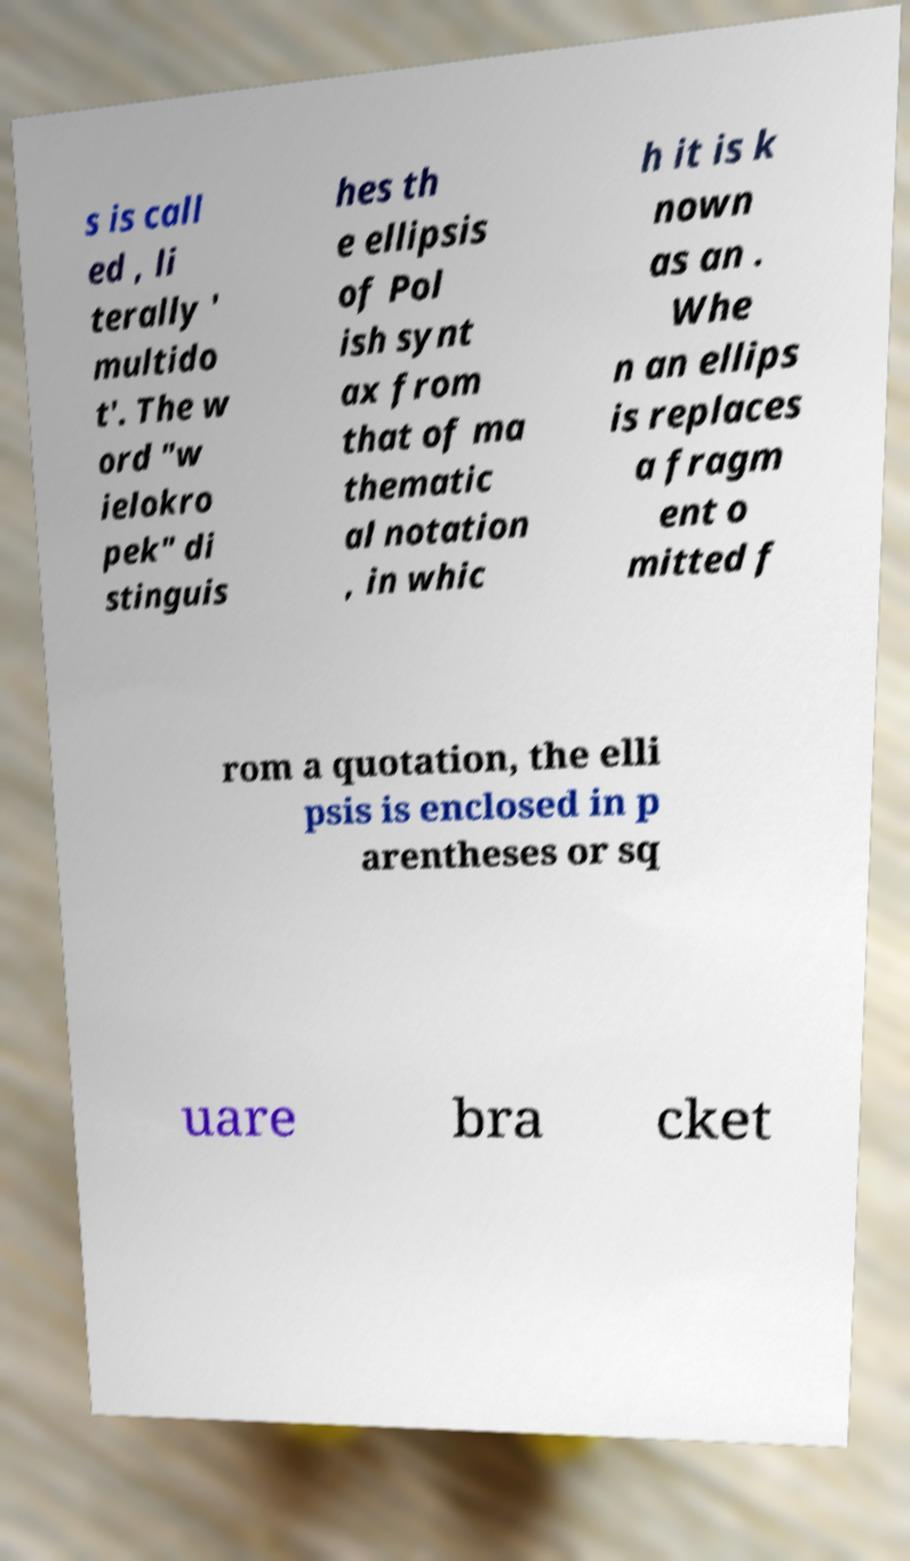There's text embedded in this image that I need extracted. Can you transcribe it verbatim? s is call ed , li terally ' multido t'. The w ord "w ielokro pek" di stinguis hes th e ellipsis of Pol ish synt ax from that of ma thematic al notation , in whic h it is k nown as an . Whe n an ellips is replaces a fragm ent o mitted f rom a quotation, the elli psis is enclosed in p arentheses or sq uare bra cket 